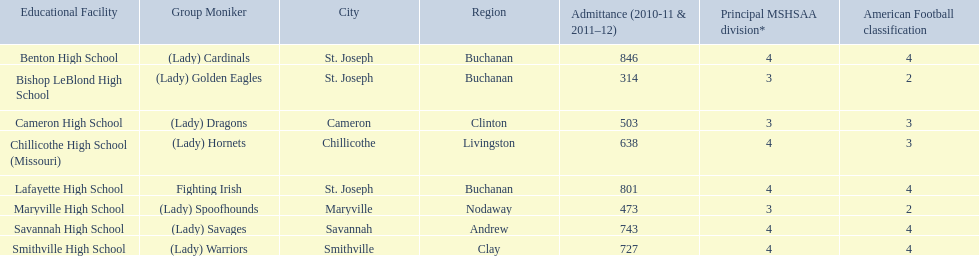What is the lowest number of students enrolled at a school as listed here? 314. What school has 314 students enrolled? Bishop LeBlond High School. 